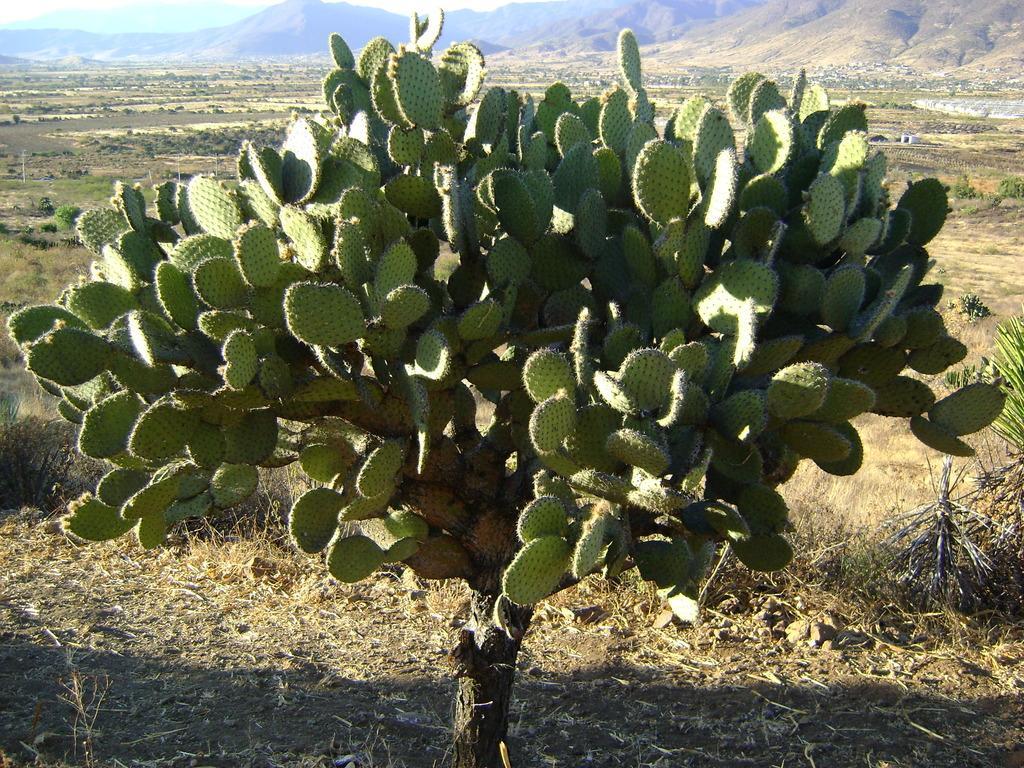In one or two sentences, can you explain what this image depicts? In this picture there is a green cactus plant in the front. Behind there is a ground and some mountains. 